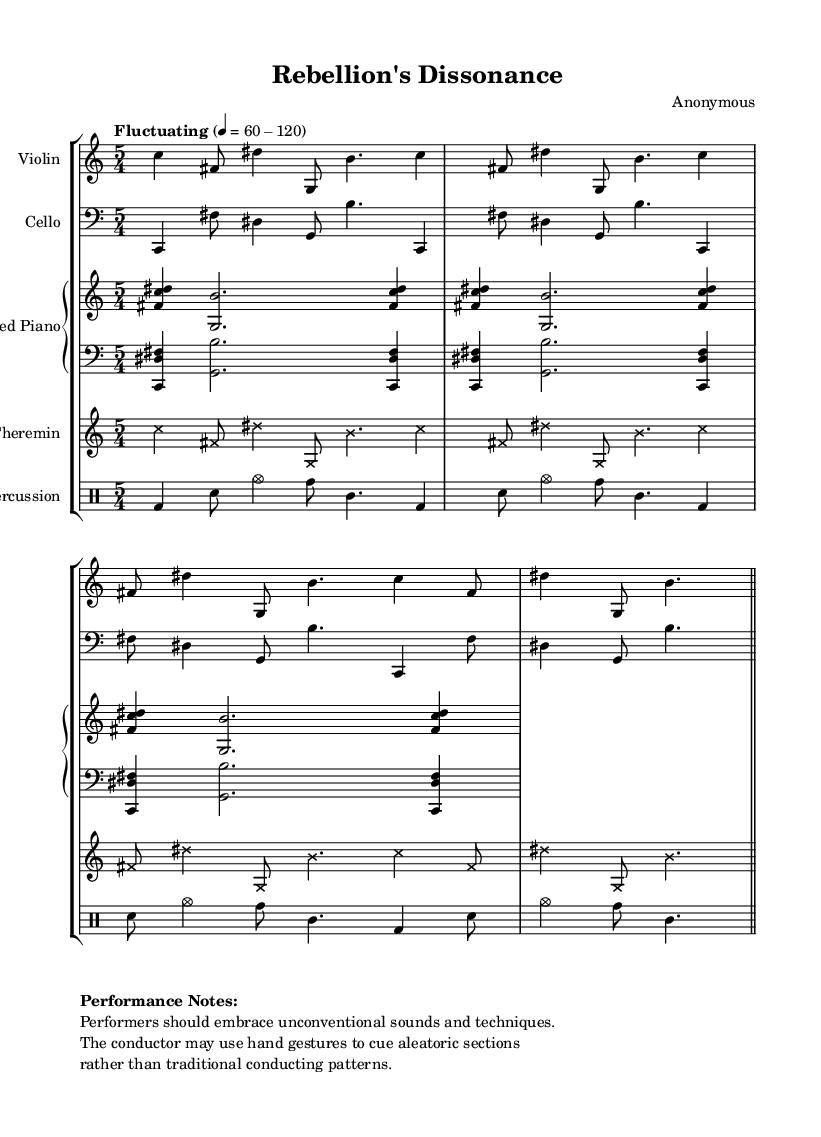What is the time signature of this music? The time signature is indicated at the beginning of the scored sections, represented as 5/4, which means there are five beats in each measure and the quarter note gets the beat.
Answer: 5/4 What is the tempo marking of the piece? The tempo marking is described in the score as "Fluctuating" with a metronome marking of 60-120, indicating that the tempo may vary between these two beats per minute during performance.
Answer: Fluctuating 60-120 How many staves are used for the piano section? In the score, the piano is indicated as a PianoStaff, which contains two separate staves: one for the right hand and one for the left hand, showing how the instrument's parts are organized.
Answer: 2 How many times is the main motif repeated in the Violin part? The main motif in the Violin part is explicitly marked to be repeated three times using the "repeat unfold" instruction, which helps performers understand the structure of the piece.
Answer: 3 What unconventional instrument is included in the orchestration? Among the orchestral instruments, the score lists a Theremin, which is known for its unique sound and the way it is played without physical contact, underscoring the piece's avant-garde nature.
Answer: Theremin What type of performance techniques are encouraged in the performance notes? The performance notes explicitly suggest embracing unconventional sounds and techniques, signaling to performers that they should explore different methods outside of traditional playing styles, fitting the avant-garde theme of the composition.
Answer: Unconventional sounds and techniques 